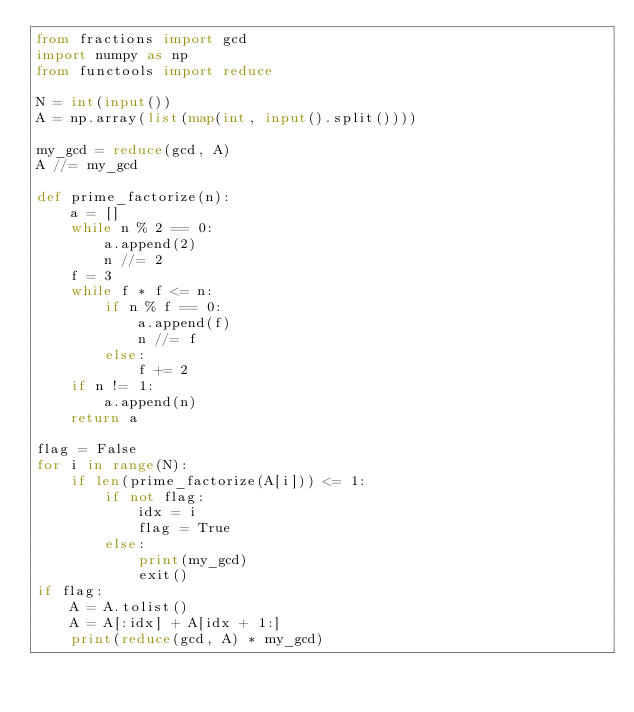<code> <loc_0><loc_0><loc_500><loc_500><_Python_>from fractions import gcd
import numpy as np
from functools import reduce

N = int(input())
A = np.array(list(map(int, input().split())))

my_gcd = reduce(gcd, A)
A //= my_gcd

def prime_factorize(n):
    a = []
    while n % 2 == 0:
        a.append(2)
        n //= 2
    f = 3
    while f * f <= n:
        if n % f == 0:
            a.append(f)
            n //= f
        else:
            f += 2
    if n != 1:
        a.append(n)
    return a

flag = False
for i in range(N):
    if len(prime_factorize(A[i])) <= 1:
        if not flag:
            idx = i
            flag = True
        else:
            print(my_gcd)
            exit()
if flag:
    A = A.tolist()
    A = A[:idx] + A[idx + 1:]
    print(reduce(gcd, A) * my_gcd)</code> 